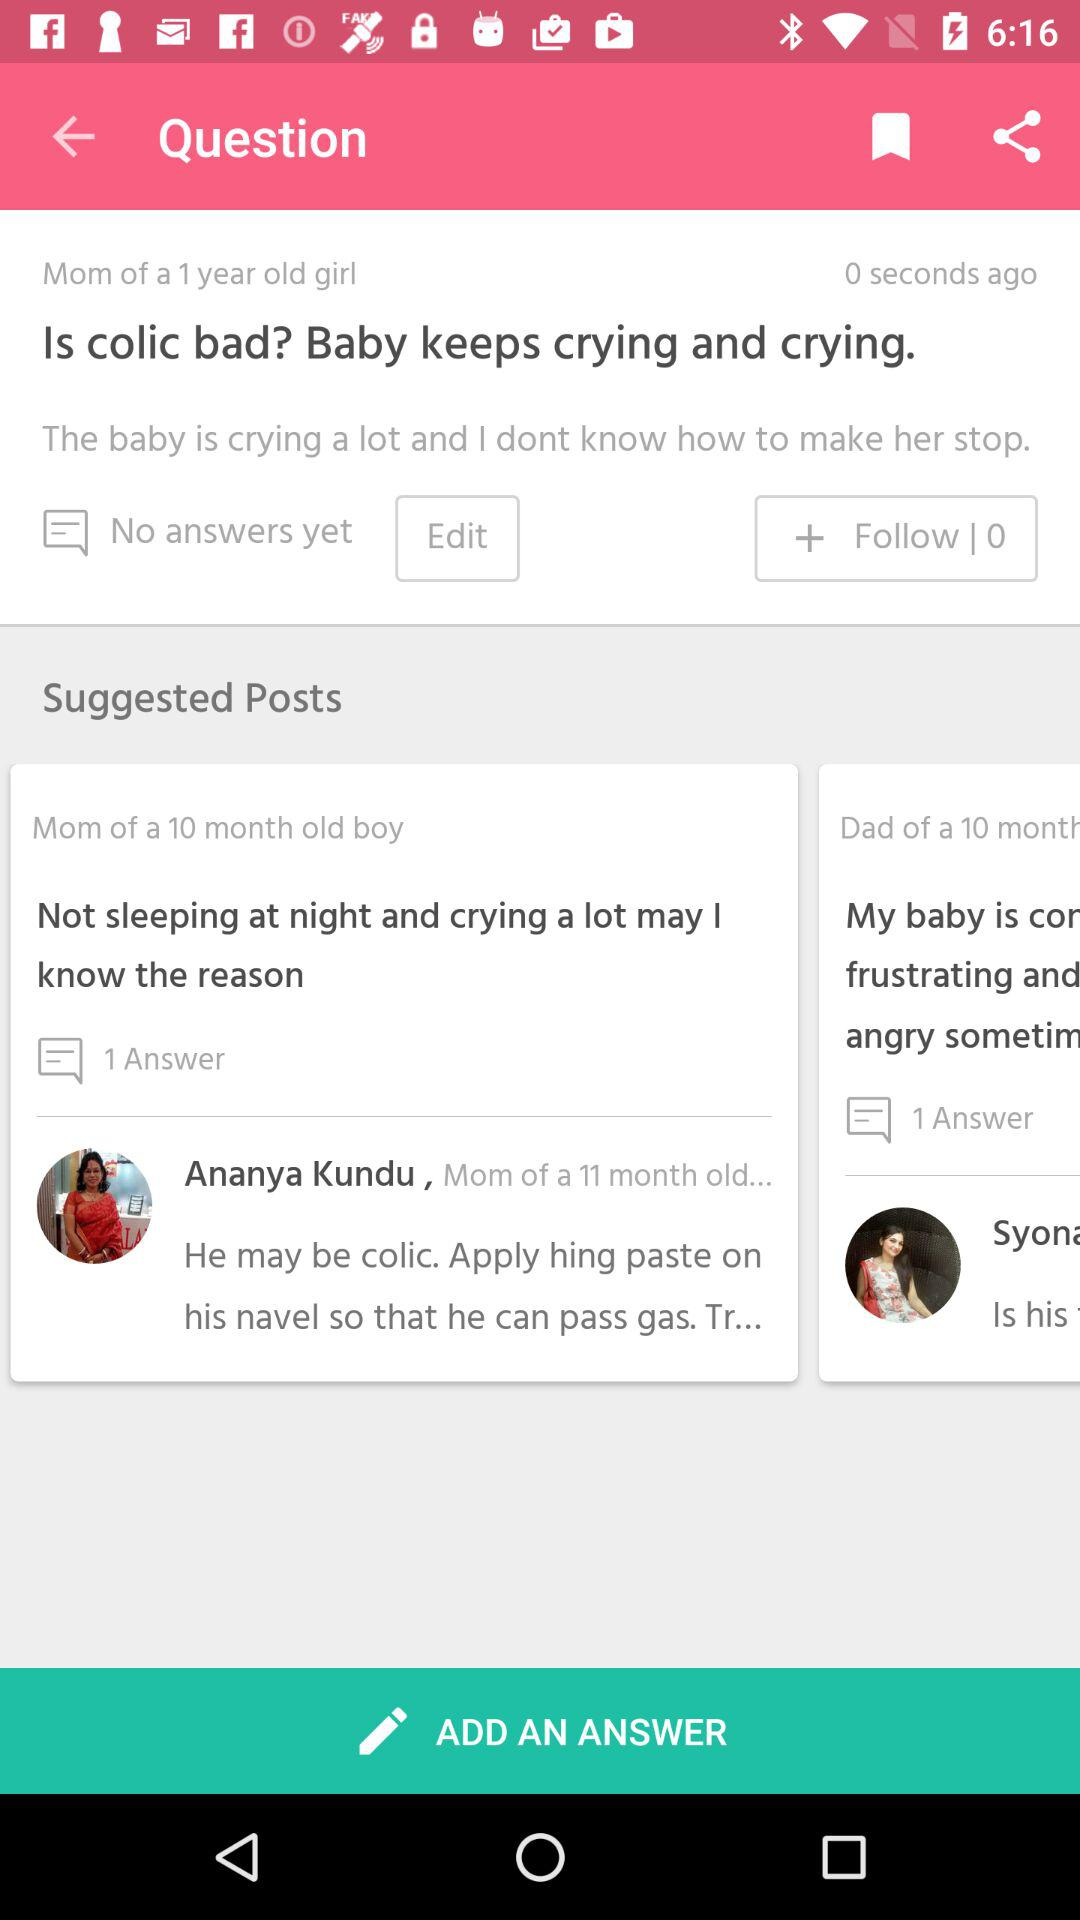How long ago did the mom of a 1-year-old girl ask the question? A mom of a 1-year-old girl asked the question 0 seconds ago. 